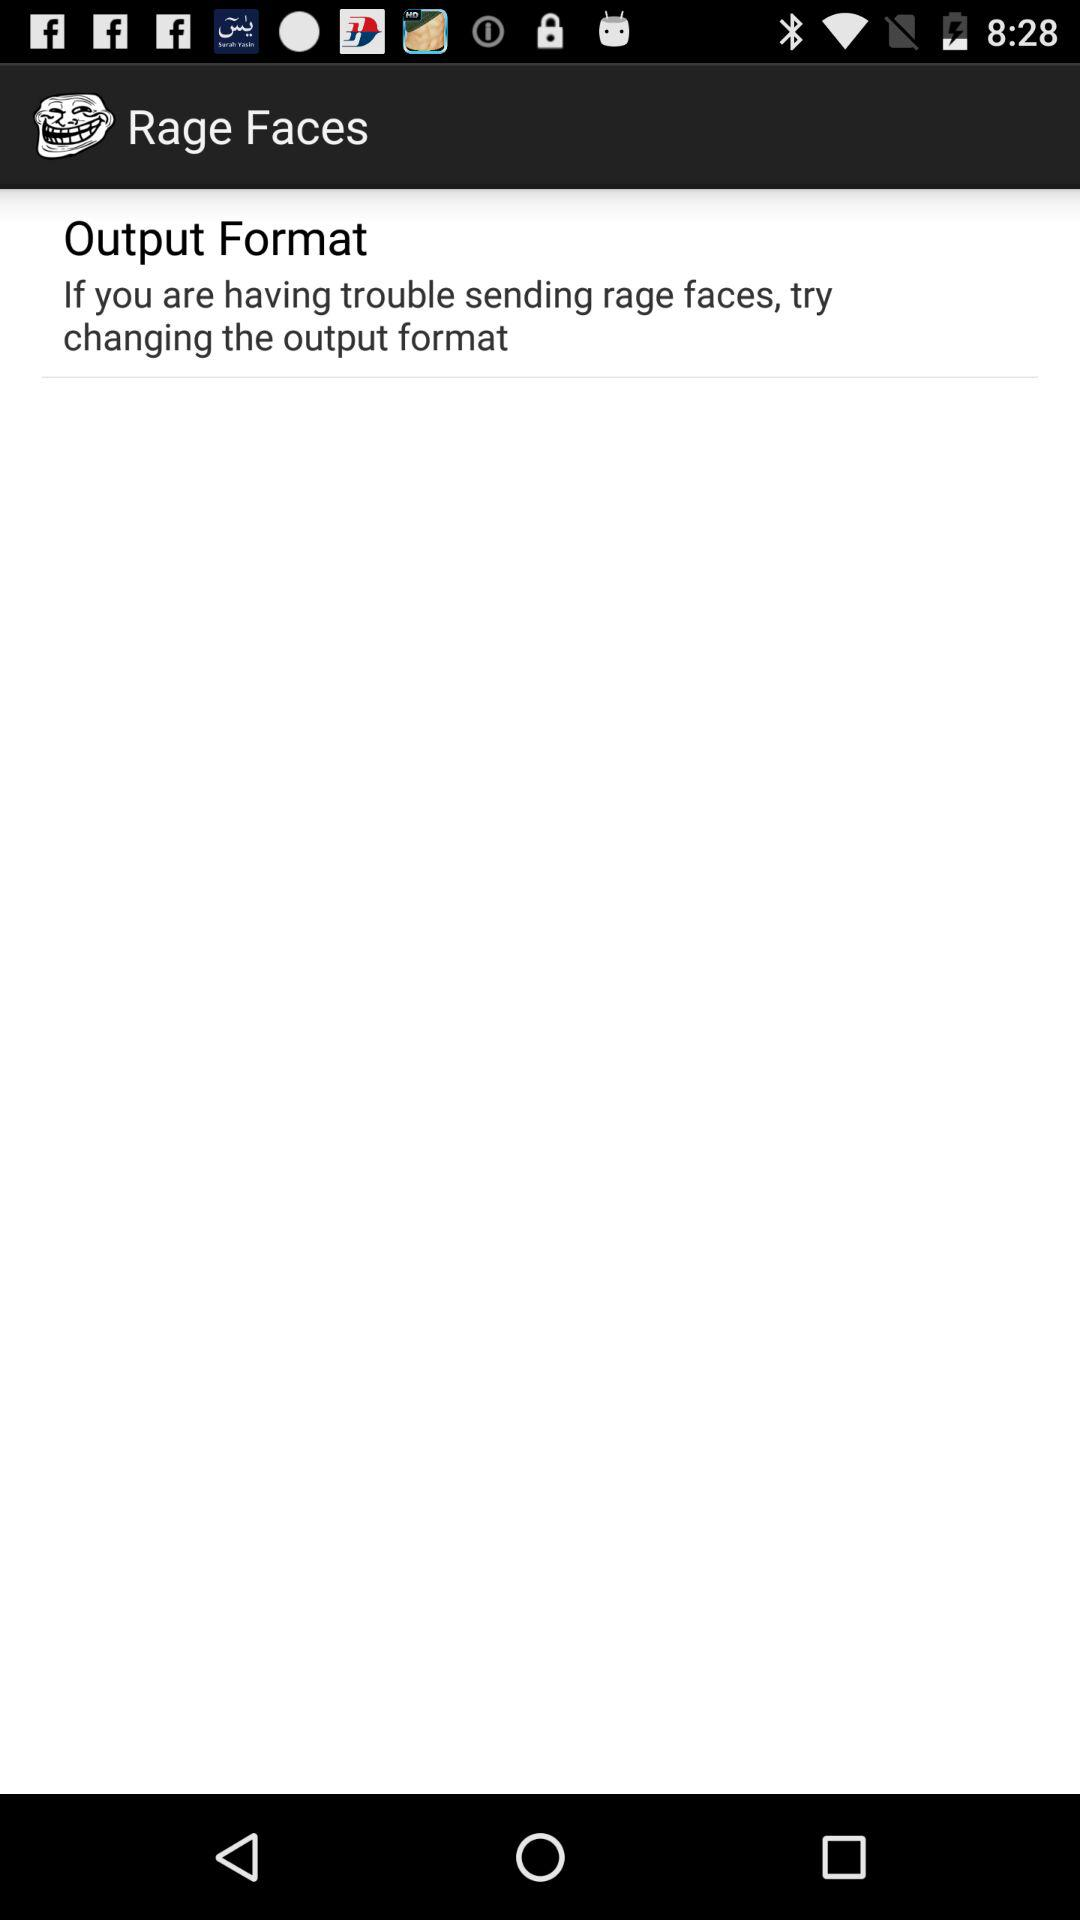What is the application name? The application name is "Rage Faces". 